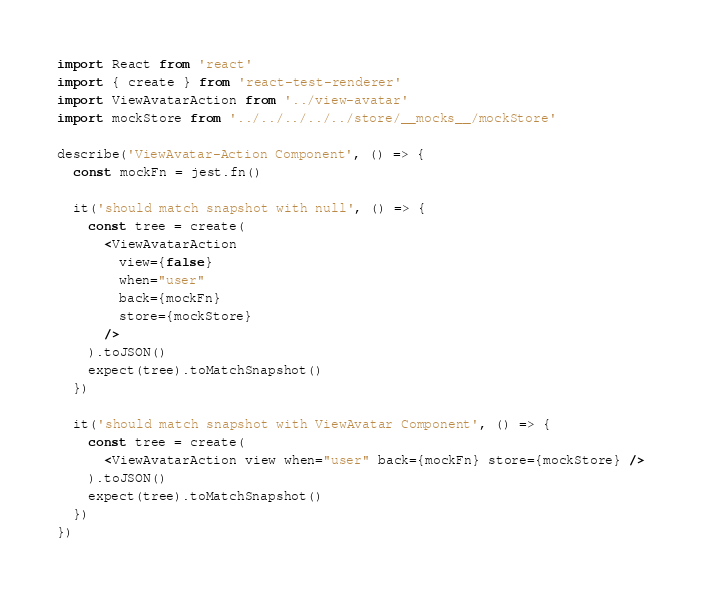Convert code to text. <code><loc_0><loc_0><loc_500><loc_500><_JavaScript_>import React from 'react'
import { create } from 'react-test-renderer'
import ViewAvatarAction from '../view-avatar'
import mockStore from '../../../../../store/__mocks__/mockStore'

describe('ViewAvatar-Action Component', () => {
  const mockFn = jest.fn()

  it('should match snapshot with null', () => {
    const tree = create(
      <ViewAvatarAction
        view={false}
        when="user"
        back={mockFn}
        store={mockStore}
      />
    ).toJSON()
    expect(tree).toMatchSnapshot()
  })

  it('should match snapshot with ViewAvatar Component', () => {
    const tree = create(
      <ViewAvatarAction view when="user" back={mockFn} store={mockStore} />
    ).toJSON()
    expect(tree).toMatchSnapshot()
  })
})
</code> 